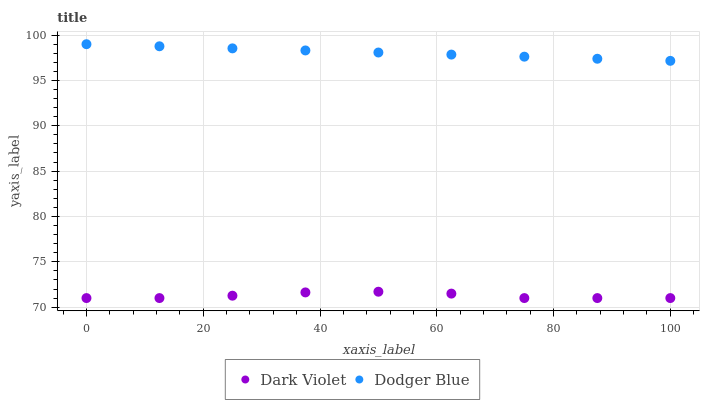Does Dark Violet have the minimum area under the curve?
Answer yes or no. Yes. Does Dodger Blue have the maximum area under the curve?
Answer yes or no. Yes. Does Dark Violet have the maximum area under the curve?
Answer yes or no. No. Is Dodger Blue the smoothest?
Answer yes or no. Yes. Is Dark Violet the roughest?
Answer yes or no. Yes. Is Dark Violet the smoothest?
Answer yes or no. No. Does Dark Violet have the lowest value?
Answer yes or no. Yes. Does Dodger Blue have the highest value?
Answer yes or no. Yes. Does Dark Violet have the highest value?
Answer yes or no. No. Is Dark Violet less than Dodger Blue?
Answer yes or no. Yes. Is Dodger Blue greater than Dark Violet?
Answer yes or no. Yes. Does Dark Violet intersect Dodger Blue?
Answer yes or no. No. 